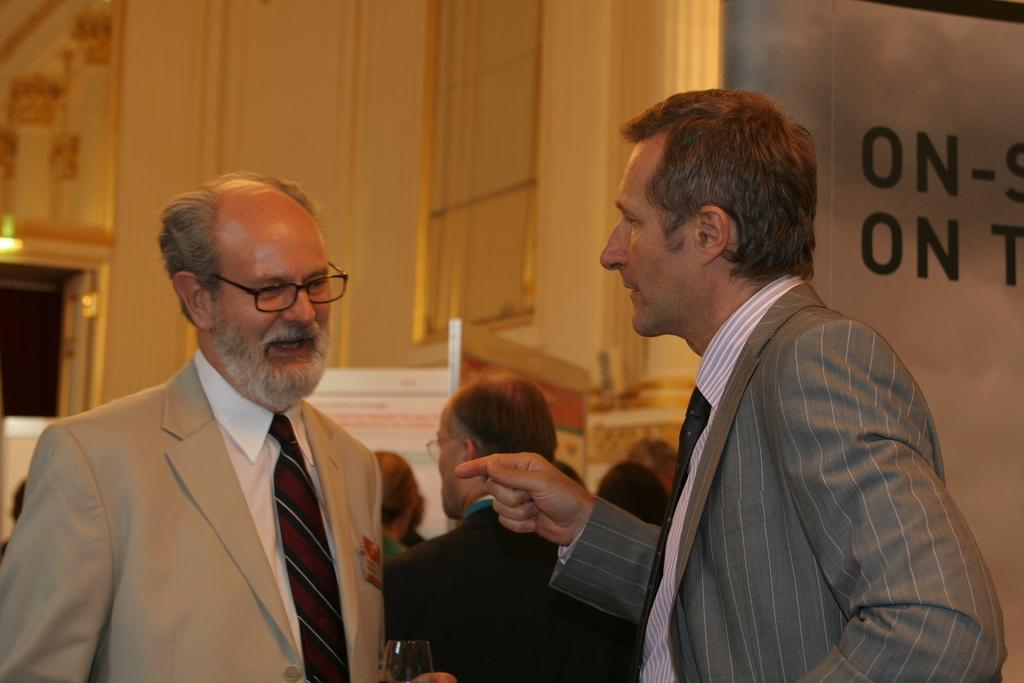What is happening in the image? There are people standing in the image. What is the man holding in the image? The man is holding a glass. What can be seen in the background of the image? There is a wall visible in the image. What type of signage is present in the image? There are boards with text on them in the image. How many forks can be seen in the image? There are no forks present in the image. What type of business is being conducted in the image? The image does not depict any specific business activity. 